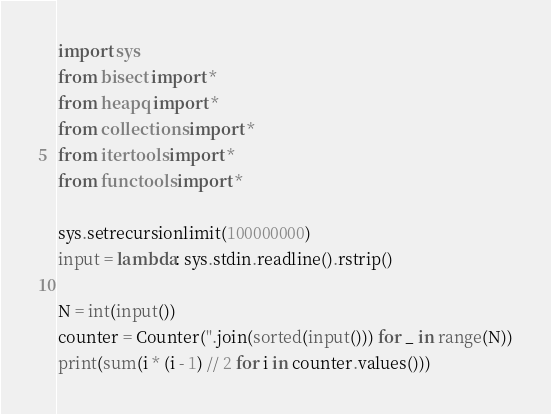Convert code to text. <code><loc_0><loc_0><loc_500><loc_500><_Python_>import sys
from bisect import *
from heapq import *
from collections import *
from itertools import *
from functools import *

sys.setrecursionlimit(100000000)
input = lambda: sys.stdin.readline().rstrip()

N = int(input())
counter = Counter(''.join(sorted(input())) for _ in range(N))
print(sum(i * (i - 1) // 2 for i in counter.values()))

</code> 